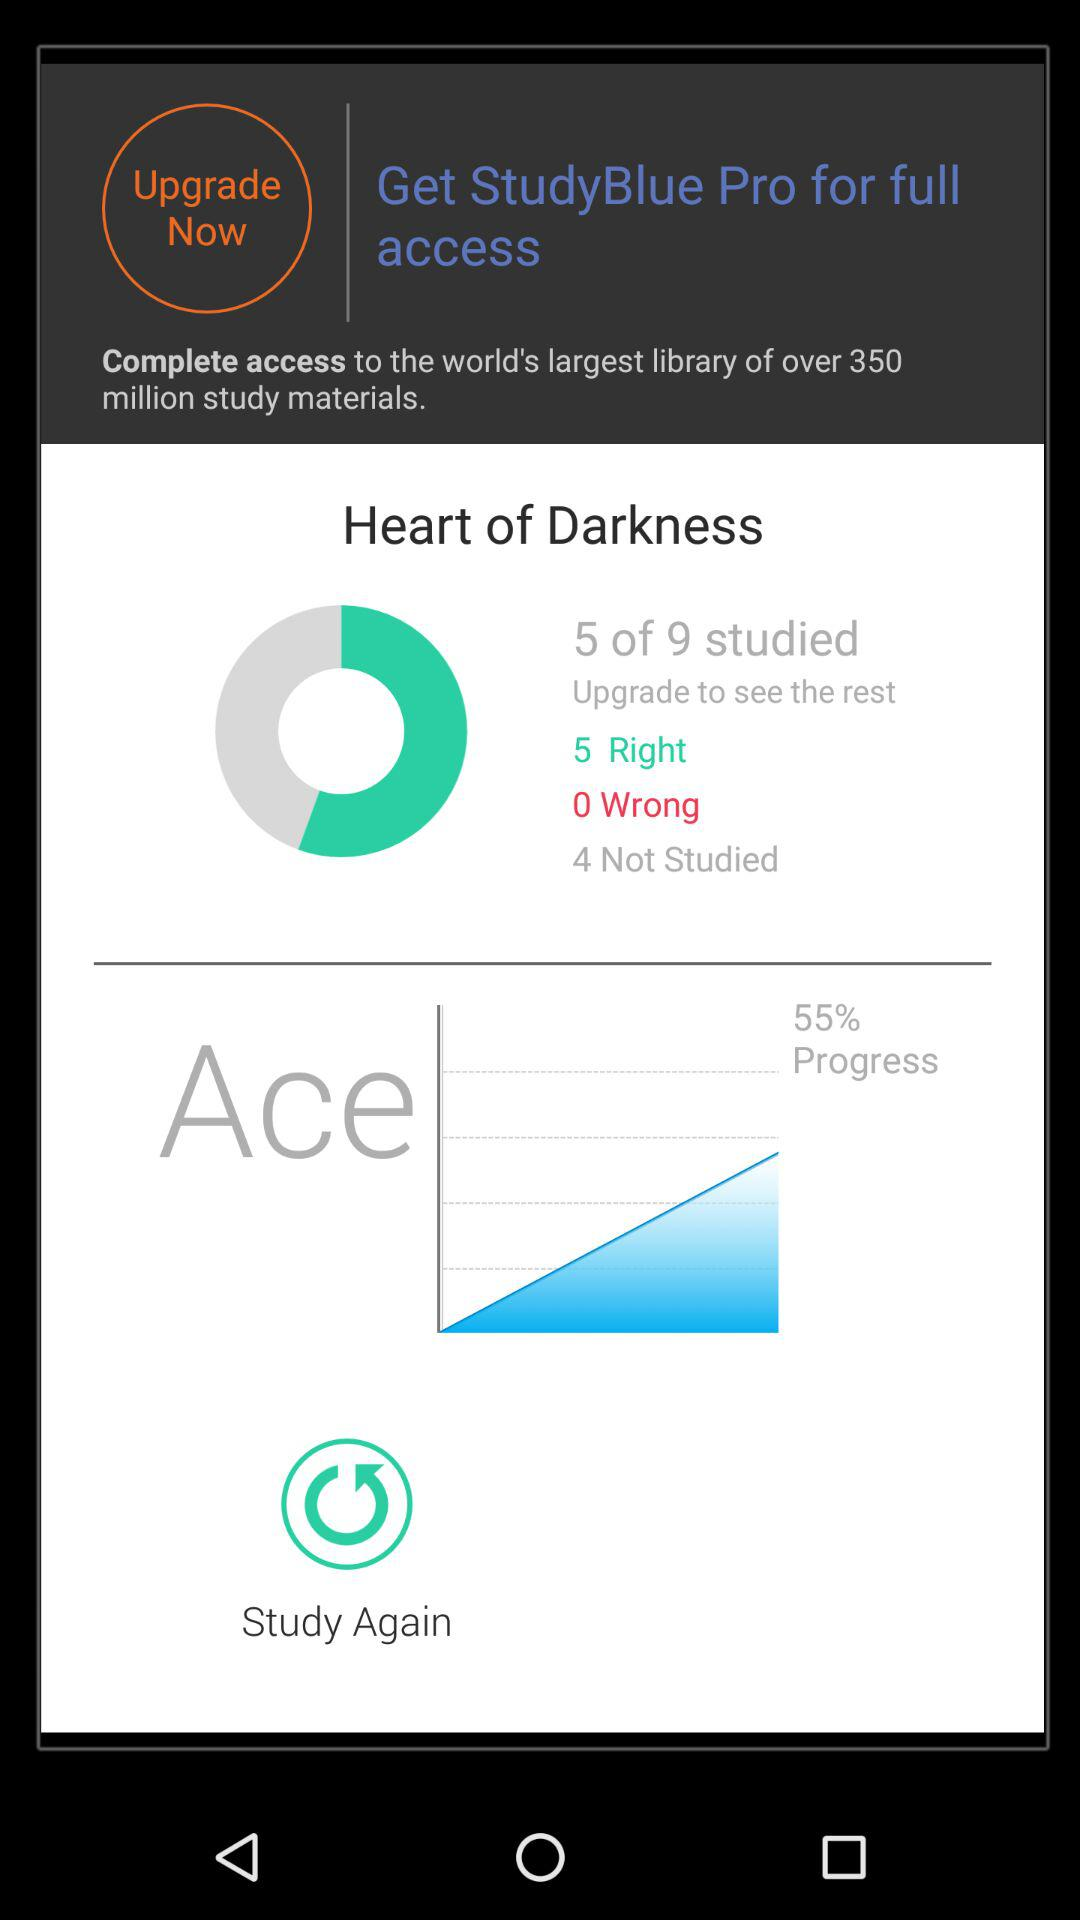How many total rights are there? There are a total of 5 rights. 